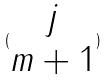<formula> <loc_0><loc_0><loc_500><loc_500>( \begin{matrix} j \\ m + 1 \end{matrix} )</formula> 